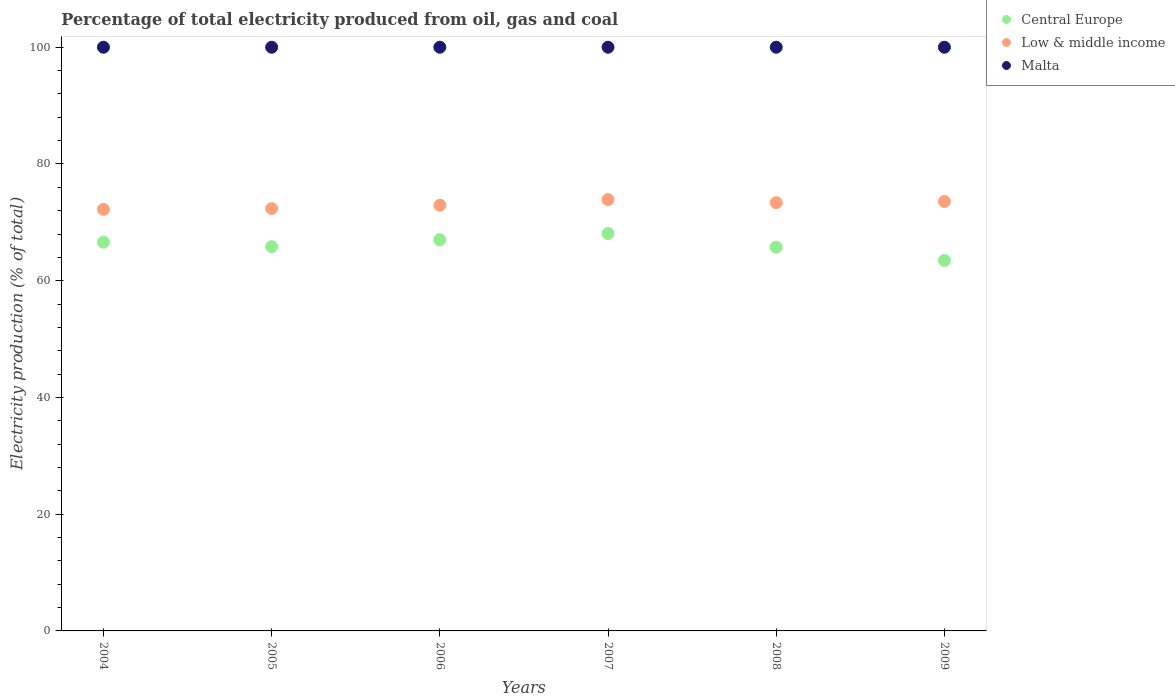How many different coloured dotlines are there?
Your response must be concise. 3. Is the number of dotlines equal to the number of legend labels?
Give a very brief answer. Yes. What is the electricity production in in Malta in 2007?
Provide a succinct answer. 100. Across all years, what is the maximum electricity production in in Central Europe?
Give a very brief answer. 68.08. In which year was the electricity production in in Central Europe maximum?
Offer a very short reply. 2007. What is the total electricity production in in Low & middle income in the graph?
Provide a short and direct response. 438.38. What is the difference between the electricity production in in Central Europe in 2005 and that in 2008?
Your answer should be very brief. 0.09. What is the difference between the electricity production in in Central Europe in 2007 and the electricity production in in Low & middle income in 2009?
Provide a short and direct response. -5.5. What is the average electricity production in in Central Europe per year?
Offer a terse response. 66.12. In the year 2004, what is the difference between the electricity production in in Low & middle income and electricity production in in Central Europe?
Make the answer very short. 5.63. In how many years, is the electricity production in in Low & middle income greater than 88 %?
Make the answer very short. 0. What is the ratio of the electricity production in in Central Europe in 2007 to that in 2008?
Provide a short and direct response. 1.04. Is the electricity production in in Malta in 2006 less than that in 2008?
Provide a short and direct response. No. Is the difference between the electricity production in in Low & middle income in 2007 and 2009 greater than the difference between the electricity production in in Central Europe in 2007 and 2009?
Keep it short and to the point. No. What is the difference between the highest and the lowest electricity production in in Low & middle income?
Offer a terse response. 1.67. Is the sum of the electricity production in in Central Europe in 2005 and 2008 greater than the maximum electricity production in in Low & middle income across all years?
Make the answer very short. Yes. Does the electricity production in in Malta monotonically increase over the years?
Make the answer very short. No. How many years are there in the graph?
Ensure brevity in your answer.  6. What is the difference between two consecutive major ticks on the Y-axis?
Provide a succinct answer. 20. Does the graph contain any zero values?
Give a very brief answer. No. How are the legend labels stacked?
Provide a succinct answer. Vertical. What is the title of the graph?
Provide a succinct answer. Percentage of total electricity produced from oil, gas and coal. Does "Guam" appear as one of the legend labels in the graph?
Keep it short and to the point. No. What is the label or title of the Y-axis?
Provide a short and direct response. Electricity production (% of total). What is the Electricity production (% of total) in Central Europe in 2004?
Provide a succinct answer. 66.6. What is the Electricity production (% of total) in Low & middle income in 2004?
Offer a terse response. 72.23. What is the Electricity production (% of total) in Malta in 2004?
Make the answer very short. 100. What is the Electricity production (% of total) in Central Europe in 2005?
Your response must be concise. 65.83. What is the Electricity production (% of total) in Low & middle income in 2005?
Provide a succinct answer. 72.36. What is the Electricity production (% of total) of Central Europe in 2006?
Your answer should be very brief. 67.03. What is the Electricity production (% of total) of Low & middle income in 2006?
Your answer should be compact. 72.94. What is the Electricity production (% of total) of Malta in 2006?
Ensure brevity in your answer.  100. What is the Electricity production (% of total) of Central Europe in 2007?
Offer a very short reply. 68.08. What is the Electricity production (% of total) of Low & middle income in 2007?
Your response must be concise. 73.9. What is the Electricity production (% of total) in Malta in 2007?
Your answer should be very brief. 100. What is the Electricity production (% of total) of Central Europe in 2008?
Provide a short and direct response. 65.74. What is the Electricity production (% of total) in Low & middle income in 2008?
Give a very brief answer. 73.37. What is the Electricity production (% of total) in Central Europe in 2009?
Your answer should be compact. 63.47. What is the Electricity production (% of total) of Low & middle income in 2009?
Provide a short and direct response. 73.58. What is the Electricity production (% of total) in Malta in 2009?
Your answer should be very brief. 100. Across all years, what is the maximum Electricity production (% of total) in Central Europe?
Provide a short and direct response. 68.08. Across all years, what is the maximum Electricity production (% of total) of Low & middle income?
Make the answer very short. 73.9. Across all years, what is the maximum Electricity production (% of total) in Malta?
Offer a terse response. 100. Across all years, what is the minimum Electricity production (% of total) of Central Europe?
Offer a very short reply. 63.47. Across all years, what is the minimum Electricity production (% of total) in Low & middle income?
Your answer should be very brief. 72.23. Across all years, what is the minimum Electricity production (% of total) of Malta?
Offer a terse response. 100. What is the total Electricity production (% of total) in Central Europe in the graph?
Your answer should be very brief. 396.75. What is the total Electricity production (% of total) in Low & middle income in the graph?
Provide a short and direct response. 438.38. What is the total Electricity production (% of total) in Malta in the graph?
Give a very brief answer. 600. What is the difference between the Electricity production (% of total) in Central Europe in 2004 and that in 2005?
Your answer should be very brief. 0.77. What is the difference between the Electricity production (% of total) in Low & middle income in 2004 and that in 2005?
Keep it short and to the point. -0.13. What is the difference between the Electricity production (% of total) in Malta in 2004 and that in 2005?
Give a very brief answer. 0. What is the difference between the Electricity production (% of total) in Central Europe in 2004 and that in 2006?
Your answer should be very brief. -0.43. What is the difference between the Electricity production (% of total) of Low & middle income in 2004 and that in 2006?
Ensure brevity in your answer.  -0.7. What is the difference between the Electricity production (% of total) in Malta in 2004 and that in 2006?
Provide a short and direct response. 0. What is the difference between the Electricity production (% of total) in Central Europe in 2004 and that in 2007?
Give a very brief answer. -1.48. What is the difference between the Electricity production (% of total) of Low & middle income in 2004 and that in 2007?
Keep it short and to the point. -1.67. What is the difference between the Electricity production (% of total) in Central Europe in 2004 and that in 2008?
Your answer should be very brief. 0.86. What is the difference between the Electricity production (% of total) in Low & middle income in 2004 and that in 2008?
Your answer should be compact. -1.14. What is the difference between the Electricity production (% of total) in Malta in 2004 and that in 2008?
Your answer should be very brief. 0. What is the difference between the Electricity production (% of total) in Central Europe in 2004 and that in 2009?
Make the answer very short. 3.13. What is the difference between the Electricity production (% of total) of Low & middle income in 2004 and that in 2009?
Keep it short and to the point. -1.35. What is the difference between the Electricity production (% of total) in Malta in 2004 and that in 2009?
Provide a short and direct response. 0. What is the difference between the Electricity production (% of total) of Central Europe in 2005 and that in 2006?
Your answer should be very brief. -1.2. What is the difference between the Electricity production (% of total) in Low & middle income in 2005 and that in 2006?
Your response must be concise. -0.57. What is the difference between the Electricity production (% of total) of Malta in 2005 and that in 2006?
Give a very brief answer. 0. What is the difference between the Electricity production (% of total) of Central Europe in 2005 and that in 2007?
Your answer should be very brief. -2.25. What is the difference between the Electricity production (% of total) of Low & middle income in 2005 and that in 2007?
Offer a very short reply. -1.54. What is the difference between the Electricity production (% of total) in Central Europe in 2005 and that in 2008?
Offer a terse response. 0.09. What is the difference between the Electricity production (% of total) in Low & middle income in 2005 and that in 2008?
Ensure brevity in your answer.  -1.01. What is the difference between the Electricity production (% of total) in Malta in 2005 and that in 2008?
Make the answer very short. 0. What is the difference between the Electricity production (% of total) in Central Europe in 2005 and that in 2009?
Make the answer very short. 2.36. What is the difference between the Electricity production (% of total) of Low & middle income in 2005 and that in 2009?
Provide a short and direct response. -1.22. What is the difference between the Electricity production (% of total) in Malta in 2005 and that in 2009?
Keep it short and to the point. 0. What is the difference between the Electricity production (% of total) of Central Europe in 2006 and that in 2007?
Offer a very short reply. -1.05. What is the difference between the Electricity production (% of total) in Low & middle income in 2006 and that in 2007?
Provide a succinct answer. -0.96. What is the difference between the Electricity production (% of total) of Central Europe in 2006 and that in 2008?
Make the answer very short. 1.29. What is the difference between the Electricity production (% of total) in Low & middle income in 2006 and that in 2008?
Provide a short and direct response. -0.44. What is the difference between the Electricity production (% of total) of Central Europe in 2006 and that in 2009?
Your response must be concise. 3.56. What is the difference between the Electricity production (% of total) of Low & middle income in 2006 and that in 2009?
Offer a terse response. -0.64. What is the difference between the Electricity production (% of total) in Malta in 2006 and that in 2009?
Your response must be concise. 0. What is the difference between the Electricity production (% of total) of Central Europe in 2007 and that in 2008?
Your answer should be compact. 2.34. What is the difference between the Electricity production (% of total) of Low & middle income in 2007 and that in 2008?
Your response must be concise. 0.53. What is the difference between the Electricity production (% of total) in Central Europe in 2007 and that in 2009?
Provide a succinct answer. 4.61. What is the difference between the Electricity production (% of total) in Low & middle income in 2007 and that in 2009?
Make the answer very short. 0.32. What is the difference between the Electricity production (% of total) in Malta in 2007 and that in 2009?
Your answer should be very brief. 0. What is the difference between the Electricity production (% of total) in Central Europe in 2008 and that in 2009?
Your response must be concise. 2.27. What is the difference between the Electricity production (% of total) of Low & middle income in 2008 and that in 2009?
Provide a succinct answer. -0.21. What is the difference between the Electricity production (% of total) of Central Europe in 2004 and the Electricity production (% of total) of Low & middle income in 2005?
Offer a very short reply. -5.76. What is the difference between the Electricity production (% of total) of Central Europe in 2004 and the Electricity production (% of total) of Malta in 2005?
Give a very brief answer. -33.4. What is the difference between the Electricity production (% of total) in Low & middle income in 2004 and the Electricity production (% of total) in Malta in 2005?
Offer a very short reply. -27.77. What is the difference between the Electricity production (% of total) in Central Europe in 2004 and the Electricity production (% of total) in Low & middle income in 2006?
Your answer should be compact. -6.33. What is the difference between the Electricity production (% of total) in Central Europe in 2004 and the Electricity production (% of total) in Malta in 2006?
Your response must be concise. -33.4. What is the difference between the Electricity production (% of total) of Low & middle income in 2004 and the Electricity production (% of total) of Malta in 2006?
Keep it short and to the point. -27.77. What is the difference between the Electricity production (% of total) in Central Europe in 2004 and the Electricity production (% of total) in Low & middle income in 2007?
Give a very brief answer. -7.3. What is the difference between the Electricity production (% of total) of Central Europe in 2004 and the Electricity production (% of total) of Malta in 2007?
Offer a terse response. -33.4. What is the difference between the Electricity production (% of total) in Low & middle income in 2004 and the Electricity production (% of total) in Malta in 2007?
Ensure brevity in your answer.  -27.77. What is the difference between the Electricity production (% of total) of Central Europe in 2004 and the Electricity production (% of total) of Low & middle income in 2008?
Your response must be concise. -6.77. What is the difference between the Electricity production (% of total) of Central Europe in 2004 and the Electricity production (% of total) of Malta in 2008?
Offer a very short reply. -33.4. What is the difference between the Electricity production (% of total) in Low & middle income in 2004 and the Electricity production (% of total) in Malta in 2008?
Keep it short and to the point. -27.77. What is the difference between the Electricity production (% of total) in Central Europe in 2004 and the Electricity production (% of total) in Low & middle income in 2009?
Your response must be concise. -6.98. What is the difference between the Electricity production (% of total) of Central Europe in 2004 and the Electricity production (% of total) of Malta in 2009?
Offer a terse response. -33.4. What is the difference between the Electricity production (% of total) in Low & middle income in 2004 and the Electricity production (% of total) in Malta in 2009?
Provide a short and direct response. -27.77. What is the difference between the Electricity production (% of total) of Central Europe in 2005 and the Electricity production (% of total) of Low & middle income in 2006?
Give a very brief answer. -7.11. What is the difference between the Electricity production (% of total) of Central Europe in 2005 and the Electricity production (% of total) of Malta in 2006?
Offer a very short reply. -34.17. What is the difference between the Electricity production (% of total) of Low & middle income in 2005 and the Electricity production (% of total) of Malta in 2006?
Your answer should be compact. -27.64. What is the difference between the Electricity production (% of total) in Central Europe in 2005 and the Electricity production (% of total) in Low & middle income in 2007?
Provide a succinct answer. -8.07. What is the difference between the Electricity production (% of total) of Central Europe in 2005 and the Electricity production (% of total) of Malta in 2007?
Provide a short and direct response. -34.17. What is the difference between the Electricity production (% of total) in Low & middle income in 2005 and the Electricity production (% of total) in Malta in 2007?
Provide a short and direct response. -27.64. What is the difference between the Electricity production (% of total) in Central Europe in 2005 and the Electricity production (% of total) in Low & middle income in 2008?
Your answer should be compact. -7.54. What is the difference between the Electricity production (% of total) in Central Europe in 2005 and the Electricity production (% of total) in Malta in 2008?
Provide a succinct answer. -34.17. What is the difference between the Electricity production (% of total) in Low & middle income in 2005 and the Electricity production (% of total) in Malta in 2008?
Your response must be concise. -27.64. What is the difference between the Electricity production (% of total) of Central Europe in 2005 and the Electricity production (% of total) of Low & middle income in 2009?
Offer a terse response. -7.75. What is the difference between the Electricity production (% of total) of Central Europe in 2005 and the Electricity production (% of total) of Malta in 2009?
Offer a very short reply. -34.17. What is the difference between the Electricity production (% of total) of Low & middle income in 2005 and the Electricity production (% of total) of Malta in 2009?
Provide a succinct answer. -27.64. What is the difference between the Electricity production (% of total) in Central Europe in 2006 and the Electricity production (% of total) in Low & middle income in 2007?
Keep it short and to the point. -6.87. What is the difference between the Electricity production (% of total) of Central Europe in 2006 and the Electricity production (% of total) of Malta in 2007?
Ensure brevity in your answer.  -32.97. What is the difference between the Electricity production (% of total) of Low & middle income in 2006 and the Electricity production (% of total) of Malta in 2007?
Offer a terse response. -27.06. What is the difference between the Electricity production (% of total) in Central Europe in 2006 and the Electricity production (% of total) in Low & middle income in 2008?
Provide a short and direct response. -6.34. What is the difference between the Electricity production (% of total) of Central Europe in 2006 and the Electricity production (% of total) of Malta in 2008?
Keep it short and to the point. -32.97. What is the difference between the Electricity production (% of total) in Low & middle income in 2006 and the Electricity production (% of total) in Malta in 2008?
Provide a succinct answer. -27.06. What is the difference between the Electricity production (% of total) in Central Europe in 2006 and the Electricity production (% of total) in Low & middle income in 2009?
Your answer should be compact. -6.55. What is the difference between the Electricity production (% of total) of Central Europe in 2006 and the Electricity production (% of total) of Malta in 2009?
Your response must be concise. -32.97. What is the difference between the Electricity production (% of total) in Low & middle income in 2006 and the Electricity production (% of total) in Malta in 2009?
Provide a succinct answer. -27.06. What is the difference between the Electricity production (% of total) of Central Europe in 2007 and the Electricity production (% of total) of Low & middle income in 2008?
Your answer should be compact. -5.29. What is the difference between the Electricity production (% of total) of Central Europe in 2007 and the Electricity production (% of total) of Malta in 2008?
Keep it short and to the point. -31.92. What is the difference between the Electricity production (% of total) in Low & middle income in 2007 and the Electricity production (% of total) in Malta in 2008?
Your answer should be compact. -26.1. What is the difference between the Electricity production (% of total) in Central Europe in 2007 and the Electricity production (% of total) in Low & middle income in 2009?
Your answer should be compact. -5.5. What is the difference between the Electricity production (% of total) of Central Europe in 2007 and the Electricity production (% of total) of Malta in 2009?
Your response must be concise. -31.92. What is the difference between the Electricity production (% of total) in Low & middle income in 2007 and the Electricity production (% of total) in Malta in 2009?
Provide a succinct answer. -26.1. What is the difference between the Electricity production (% of total) of Central Europe in 2008 and the Electricity production (% of total) of Low & middle income in 2009?
Give a very brief answer. -7.84. What is the difference between the Electricity production (% of total) in Central Europe in 2008 and the Electricity production (% of total) in Malta in 2009?
Ensure brevity in your answer.  -34.26. What is the difference between the Electricity production (% of total) in Low & middle income in 2008 and the Electricity production (% of total) in Malta in 2009?
Make the answer very short. -26.63. What is the average Electricity production (% of total) of Central Europe per year?
Offer a very short reply. 66.12. What is the average Electricity production (% of total) in Low & middle income per year?
Your answer should be compact. 73.06. What is the average Electricity production (% of total) of Malta per year?
Ensure brevity in your answer.  100. In the year 2004, what is the difference between the Electricity production (% of total) of Central Europe and Electricity production (% of total) of Low & middle income?
Your response must be concise. -5.63. In the year 2004, what is the difference between the Electricity production (% of total) in Central Europe and Electricity production (% of total) in Malta?
Provide a short and direct response. -33.4. In the year 2004, what is the difference between the Electricity production (% of total) of Low & middle income and Electricity production (% of total) of Malta?
Your answer should be very brief. -27.77. In the year 2005, what is the difference between the Electricity production (% of total) of Central Europe and Electricity production (% of total) of Low & middle income?
Ensure brevity in your answer.  -6.53. In the year 2005, what is the difference between the Electricity production (% of total) of Central Europe and Electricity production (% of total) of Malta?
Make the answer very short. -34.17. In the year 2005, what is the difference between the Electricity production (% of total) of Low & middle income and Electricity production (% of total) of Malta?
Your response must be concise. -27.64. In the year 2006, what is the difference between the Electricity production (% of total) of Central Europe and Electricity production (% of total) of Low & middle income?
Ensure brevity in your answer.  -5.91. In the year 2006, what is the difference between the Electricity production (% of total) in Central Europe and Electricity production (% of total) in Malta?
Make the answer very short. -32.97. In the year 2006, what is the difference between the Electricity production (% of total) in Low & middle income and Electricity production (% of total) in Malta?
Your answer should be very brief. -27.06. In the year 2007, what is the difference between the Electricity production (% of total) of Central Europe and Electricity production (% of total) of Low & middle income?
Provide a short and direct response. -5.82. In the year 2007, what is the difference between the Electricity production (% of total) in Central Europe and Electricity production (% of total) in Malta?
Provide a succinct answer. -31.92. In the year 2007, what is the difference between the Electricity production (% of total) in Low & middle income and Electricity production (% of total) in Malta?
Give a very brief answer. -26.1. In the year 2008, what is the difference between the Electricity production (% of total) of Central Europe and Electricity production (% of total) of Low & middle income?
Provide a succinct answer. -7.63. In the year 2008, what is the difference between the Electricity production (% of total) in Central Europe and Electricity production (% of total) in Malta?
Provide a succinct answer. -34.26. In the year 2008, what is the difference between the Electricity production (% of total) in Low & middle income and Electricity production (% of total) in Malta?
Give a very brief answer. -26.63. In the year 2009, what is the difference between the Electricity production (% of total) of Central Europe and Electricity production (% of total) of Low & middle income?
Ensure brevity in your answer.  -10.11. In the year 2009, what is the difference between the Electricity production (% of total) of Central Europe and Electricity production (% of total) of Malta?
Offer a terse response. -36.53. In the year 2009, what is the difference between the Electricity production (% of total) in Low & middle income and Electricity production (% of total) in Malta?
Ensure brevity in your answer.  -26.42. What is the ratio of the Electricity production (% of total) of Central Europe in 2004 to that in 2005?
Your answer should be compact. 1.01. What is the ratio of the Electricity production (% of total) of Low & middle income in 2004 to that in 2006?
Keep it short and to the point. 0.99. What is the ratio of the Electricity production (% of total) of Malta in 2004 to that in 2006?
Make the answer very short. 1. What is the ratio of the Electricity production (% of total) in Central Europe in 2004 to that in 2007?
Make the answer very short. 0.98. What is the ratio of the Electricity production (% of total) of Low & middle income in 2004 to that in 2007?
Keep it short and to the point. 0.98. What is the ratio of the Electricity production (% of total) of Central Europe in 2004 to that in 2008?
Your response must be concise. 1.01. What is the ratio of the Electricity production (% of total) in Low & middle income in 2004 to that in 2008?
Give a very brief answer. 0.98. What is the ratio of the Electricity production (% of total) in Central Europe in 2004 to that in 2009?
Provide a short and direct response. 1.05. What is the ratio of the Electricity production (% of total) in Low & middle income in 2004 to that in 2009?
Make the answer very short. 0.98. What is the ratio of the Electricity production (% of total) of Central Europe in 2005 to that in 2006?
Keep it short and to the point. 0.98. What is the ratio of the Electricity production (% of total) of Central Europe in 2005 to that in 2007?
Ensure brevity in your answer.  0.97. What is the ratio of the Electricity production (% of total) in Low & middle income in 2005 to that in 2007?
Offer a terse response. 0.98. What is the ratio of the Electricity production (% of total) of Malta in 2005 to that in 2007?
Make the answer very short. 1. What is the ratio of the Electricity production (% of total) in Central Europe in 2005 to that in 2008?
Provide a succinct answer. 1. What is the ratio of the Electricity production (% of total) of Low & middle income in 2005 to that in 2008?
Make the answer very short. 0.99. What is the ratio of the Electricity production (% of total) in Central Europe in 2005 to that in 2009?
Your answer should be very brief. 1.04. What is the ratio of the Electricity production (% of total) in Low & middle income in 2005 to that in 2009?
Offer a terse response. 0.98. What is the ratio of the Electricity production (% of total) of Central Europe in 2006 to that in 2007?
Give a very brief answer. 0.98. What is the ratio of the Electricity production (% of total) in Low & middle income in 2006 to that in 2007?
Your answer should be very brief. 0.99. What is the ratio of the Electricity production (% of total) in Central Europe in 2006 to that in 2008?
Offer a terse response. 1.02. What is the ratio of the Electricity production (% of total) of Malta in 2006 to that in 2008?
Your response must be concise. 1. What is the ratio of the Electricity production (% of total) in Central Europe in 2006 to that in 2009?
Provide a succinct answer. 1.06. What is the ratio of the Electricity production (% of total) of Low & middle income in 2006 to that in 2009?
Your answer should be very brief. 0.99. What is the ratio of the Electricity production (% of total) in Malta in 2006 to that in 2009?
Provide a short and direct response. 1. What is the ratio of the Electricity production (% of total) of Central Europe in 2007 to that in 2008?
Ensure brevity in your answer.  1.04. What is the ratio of the Electricity production (% of total) in Malta in 2007 to that in 2008?
Offer a very short reply. 1. What is the ratio of the Electricity production (% of total) of Central Europe in 2007 to that in 2009?
Ensure brevity in your answer.  1.07. What is the ratio of the Electricity production (% of total) in Low & middle income in 2007 to that in 2009?
Your answer should be compact. 1. What is the ratio of the Electricity production (% of total) of Malta in 2007 to that in 2009?
Your answer should be compact. 1. What is the ratio of the Electricity production (% of total) of Central Europe in 2008 to that in 2009?
Keep it short and to the point. 1.04. What is the difference between the highest and the second highest Electricity production (% of total) in Central Europe?
Your answer should be compact. 1.05. What is the difference between the highest and the second highest Electricity production (% of total) of Low & middle income?
Your response must be concise. 0.32. What is the difference between the highest and the second highest Electricity production (% of total) of Malta?
Keep it short and to the point. 0. What is the difference between the highest and the lowest Electricity production (% of total) of Central Europe?
Provide a succinct answer. 4.61. 